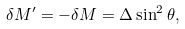Convert formula to latex. <formula><loc_0><loc_0><loc_500><loc_500>\delta M ^ { \prime } = - \delta M = \Delta \sin ^ { 2 } \theta ,</formula> 